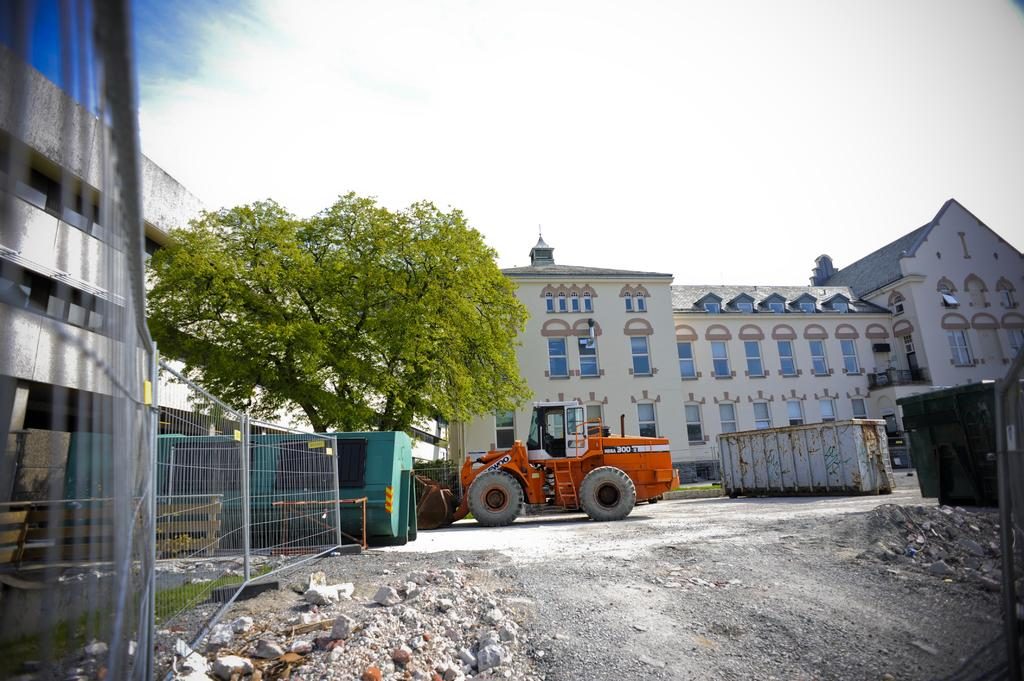What type of structures can be seen in the image? There are buildings in the image. What feature of the buildings is visible in the image? There are windows visible in the image. What natural element is present in the image? There is a tree in the image. What mode of transportation can be seen in the image? A vehicle is present in the image. What type of barrier is present in the image? There is fencing in the image. What type of storage units are visible in the image? Containers are visible in the image. What type of geological feature is present in the image? Rocks are present in the image. What part of the natural environment is visible in the image? The sky is visible in the image. What type of drug is being used by the people in the image? There is no indication of any drug use in the image. What hobbies are the people in the image engaged in? There is no information about the people's hobbies in the image. 